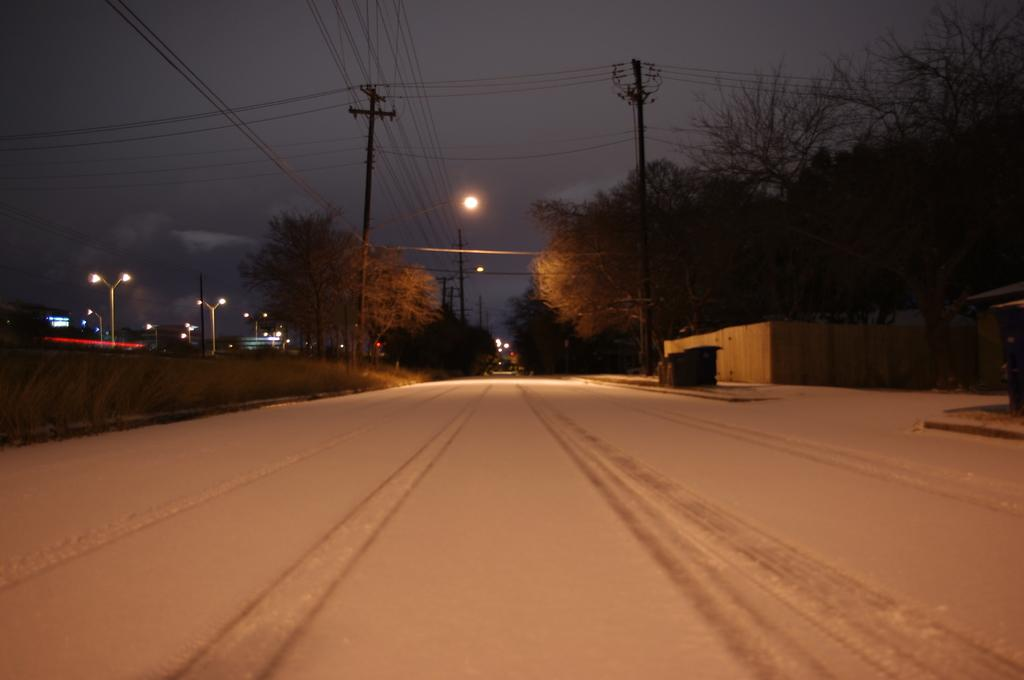What can be seen on the road in the image? There are objects on the road in the image. What is visible in the background of the image? Poles with wires, trees, and buildings are present in the background of the image. Can you describe the structure in the image? There is a shed in the image. What is visible at the top of the image? The sky is visible at the top of the image. What month is it in the image? The month cannot be determined from the image, as it does not contain any information about the time of year. Can you see anyone's knee in the image? There are no people visible in the image, so it is not possible to see anyone's knee. 